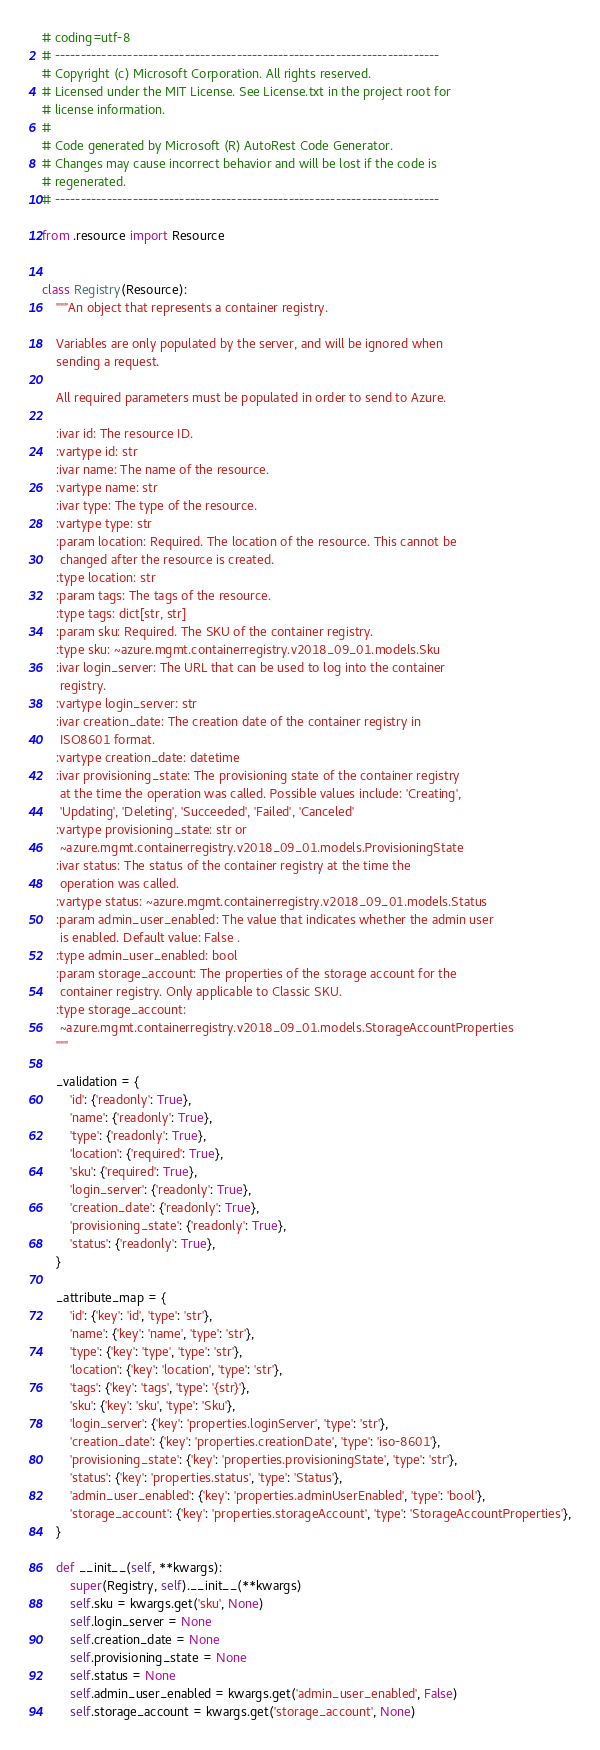Convert code to text. <code><loc_0><loc_0><loc_500><loc_500><_Python_># coding=utf-8
# --------------------------------------------------------------------------
# Copyright (c) Microsoft Corporation. All rights reserved.
# Licensed under the MIT License. See License.txt in the project root for
# license information.
#
# Code generated by Microsoft (R) AutoRest Code Generator.
# Changes may cause incorrect behavior and will be lost if the code is
# regenerated.
# --------------------------------------------------------------------------

from .resource import Resource


class Registry(Resource):
    """An object that represents a container registry.

    Variables are only populated by the server, and will be ignored when
    sending a request.

    All required parameters must be populated in order to send to Azure.

    :ivar id: The resource ID.
    :vartype id: str
    :ivar name: The name of the resource.
    :vartype name: str
    :ivar type: The type of the resource.
    :vartype type: str
    :param location: Required. The location of the resource. This cannot be
     changed after the resource is created.
    :type location: str
    :param tags: The tags of the resource.
    :type tags: dict[str, str]
    :param sku: Required. The SKU of the container registry.
    :type sku: ~azure.mgmt.containerregistry.v2018_09_01.models.Sku
    :ivar login_server: The URL that can be used to log into the container
     registry.
    :vartype login_server: str
    :ivar creation_date: The creation date of the container registry in
     ISO8601 format.
    :vartype creation_date: datetime
    :ivar provisioning_state: The provisioning state of the container registry
     at the time the operation was called. Possible values include: 'Creating',
     'Updating', 'Deleting', 'Succeeded', 'Failed', 'Canceled'
    :vartype provisioning_state: str or
     ~azure.mgmt.containerregistry.v2018_09_01.models.ProvisioningState
    :ivar status: The status of the container registry at the time the
     operation was called.
    :vartype status: ~azure.mgmt.containerregistry.v2018_09_01.models.Status
    :param admin_user_enabled: The value that indicates whether the admin user
     is enabled. Default value: False .
    :type admin_user_enabled: bool
    :param storage_account: The properties of the storage account for the
     container registry. Only applicable to Classic SKU.
    :type storage_account:
     ~azure.mgmt.containerregistry.v2018_09_01.models.StorageAccountProperties
    """

    _validation = {
        'id': {'readonly': True},
        'name': {'readonly': True},
        'type': {'readonly': True},
        'location': {'required': True},
        'sku': {'required': True},
        'login_server': {'readonly': True},
        'creation_date': {'readonly': True},
        'provisioning_state': {'readonly': True},
        'status': {'readonly': True},
    }

    _attribute_map = {
        'id': {'key': 'id', 'type': 'str'},
        'name': {'key': 'name', 'type': 'str'},
        'type': {'key': 'type', 'type': 'str'},
        'location': {'key': 'location', 'type': 'str'},
        'tags': {'key': 'tags', 'type': '{str}'},
        'sku': {'key': 'sku', 'type': 'Sku'},
        'login_server': {'key': 'properties.loginServer', 'type': 'str'},
        'creation_date': {'key': 'properties.creationDate', 'type': 'iso-8601'},
        'provisioning_state': {'key': 'properties.provisioningState', 'type': 'str'},
        'status': {'key': 'properties.status', 'type': 'Status'},
        'admin_user_enabled': {'key': 'properties.adminUserEnabled', 'type': 'bool'},
        'storage_account': {'key': 'properties.storageAccount', 'type': 'StorageAccountProperties'},
    }

    def __init__(self, **kwargs):
        super(Registry, self).__init__(**kwargs)
        self.sku = kwargs.get('sku', None)
        self.login_server = None
        self.creation_date = None
        self.provisioning_state = None
        self.status = None
        self.admin_user_enabled = kwargs.get('admin_user_enabled', False)
        self.storage_account = kwargs.get('storage_account', None)
</code> 